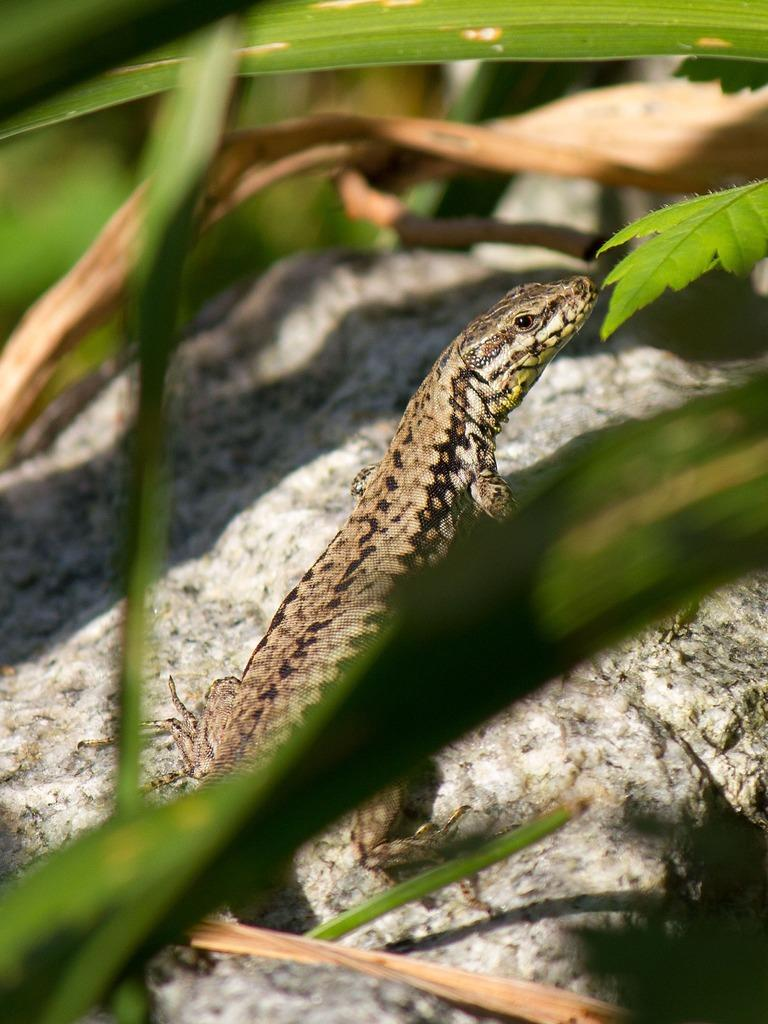What is visible in the foreground of the picture? There are leaves in the foreground of the picture. What can be seen in the center of the picture? There is a lizard-like animal on a rock in the center of the picture. How would you describe the background of the image? The background of the image is blurred. Can you tell me about the history of the woman in the sky in the image? There is no woman or sky present in the image; it features leaves in the foreground and a lizard-like animal on a rock in the center. 